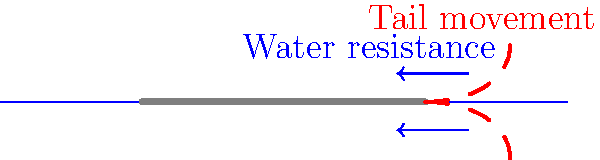In the context of fish propulsion, explain how the biomechanics of a fish's tail movement contributes to its forward motion. How might this principle be applied in the design of underwater exhibits or interactive displays in the museum to educate visitors about marine locomotion? 1. Tail movement: Fish propel themselves by oscillating their tails from side to side.

2. Force generation: As the tail moves, it pushes against the water, creating a backward force.

3. Newton's Third Law: According to Newton's Third Law, for every action, there is an equal and opposite reaction.

4. Forward thrust: The backward force on the water results in a forward thrust on the fish.

5. Vortex creation: The tail movement creates vortices in the water, which can enhance propulsion efficiency.

6. Hydrodynamics: The streamlined shape of the fish reduces drag, allowing for more efficient movement.

7. Muscle mechanics: Strong muscles in the fish's body power the tail movement, converting chemical energy to kinetic energy.

8. Application to exhibits: 
   a) Create a mechanical fish model demonstrating tail movement.
   b) Design an interactive display where visitors can control a simulated fish's tail to see how it affects movement.
   c) Use water tanks with dye injections to visualize water flow patterns around moving fish models.
   d) Develop a virtual reality experience allowing visitors to "swim" as a fish.

9. Educational value: These exhibits can help visitors understand the principles of action-reaction, energy conversion, and fluid dynamics in a relatable, marine biology context.
Answer: Fish propulsion relies on tail oscillation creating backward water force, resulting in forward thrust (Newton's Third Law). Museum exhibits can demonstrate this through mechanical models, interactive displays, and visualizations of water flow patterns. 